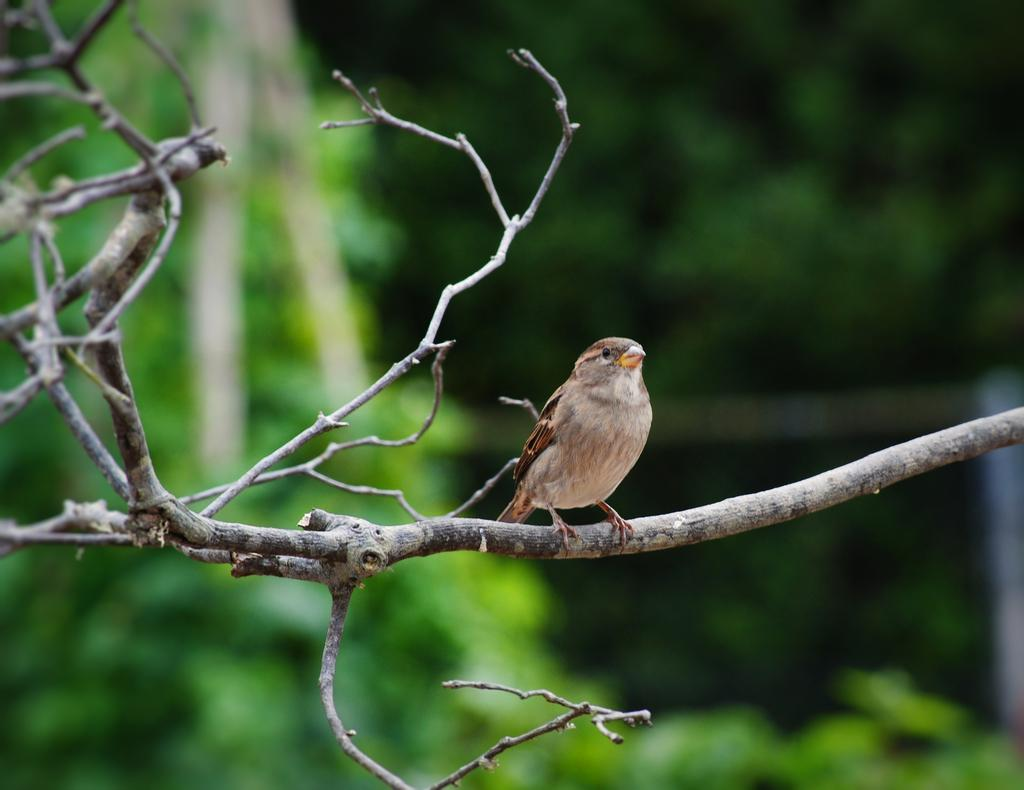What is the main subject of the image? There is a bird in the center of the image. Where is the bird located? The bird is on a branch. What can be seen in the background of the image? There are trees in the background of the image. What verse is the bird reciting in the image? There is no indication in the image that the bird is reciting a verse, as birds do not have the ability to speak or recite poetry. 